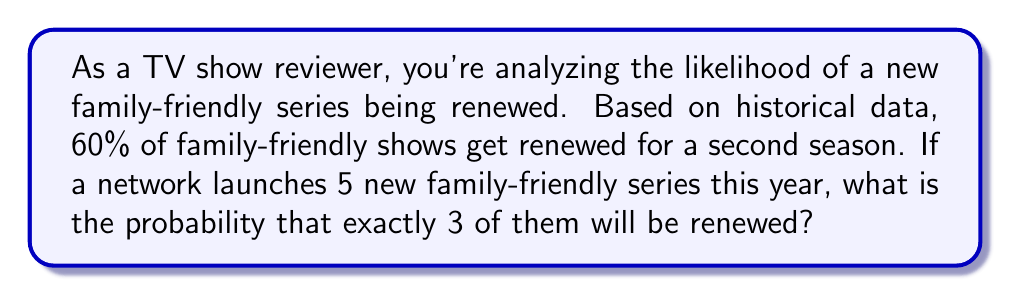Can you answer this question? To solve this problem, we'll use the binomial probability formula, as we're dealing with a fixed number of independent trials (5 new shows) with two possible outcomes for each (renewed or not renewed).

Step 1: Identify the components of the binomial probability formula:
- $n = 5$ (number of trials/shows)
- $k = 3$ (number of successes/renewals we're interested in)
- $p = 0.60$ (probability of success/renewal for each show)
- $q = 1 - p = 0.40$ (probability of failure/non-renewal for each show)

Step 2: Apply the binomial probability formula:

$$P(X = k) = \binom{n}{k} p^k q^{n-k}$$

Where $\binom{n}{k}$ is the binomial coefficient, calculated as:

$$\binom{n}{k} = \frac{n!}{k!(n-k)!}$$

Step 3: Calculate the binomial coefficient:

$$\binom{5}{3} = \frac{5!}{3!(5-3)!} = \frac{5 \cdot 4 \cdot 3!}{3! \cdot 2!} = 10$$

Step 4: Plug all values into the binomial probability formula:

$$P(X = 3) = 10 \cdot (0.60)^3 \cdot (0.40)^{5-3}$$

Step 5: Calculate the final probability:

$$P(X = 3) = 10 \cdot 0.216 \cdot 0.16 = 0.3456$$

Therefore, the probability of exactly 3 out of 5 new family-friendly series being renewed is 0.3456 or 34.56%.
Answer: 0.3456 